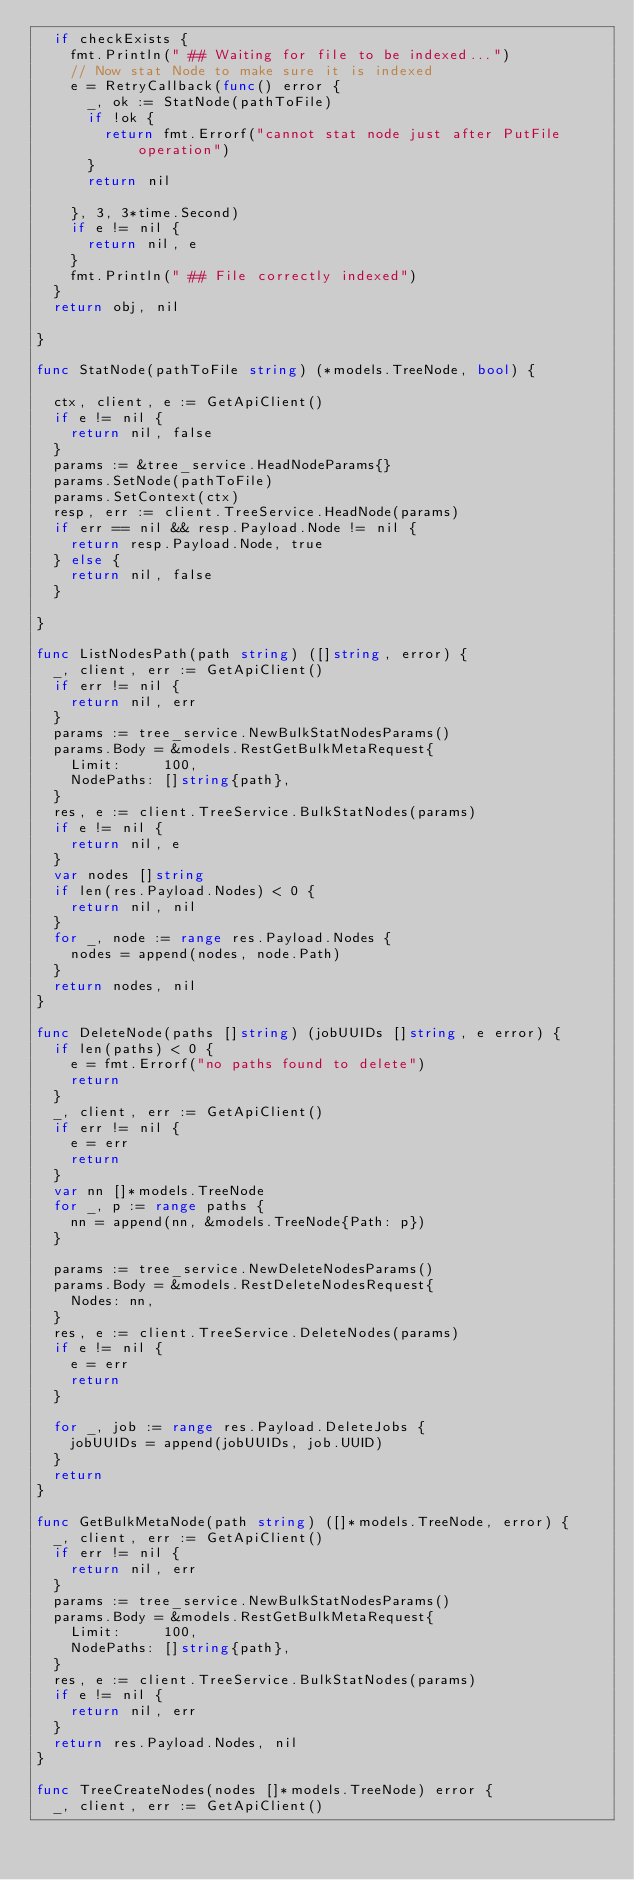<code> <loc_0><loc_0><loc_500><loc_500><_Go_>	if checkExists {
		fmt.Println(" ## Waiting for file to be indexed...")
		// Now stat Node to make sure it is indexed
		e = RetryCallback(func() error {
			_, ok := StatNode(pathToFile)
			if !ok {
				return fmt.Errorf("cannot stat node just after PutFile operation")
			}
			return nil

		}, 3, 3*time.Second)
		if e != nil {
			return nil, e
		}
		fmt.Println(" ## File correctly indexed")
	}
	return obj, nil

}

func StatNode(pathToFile string) (*models.TreeNode, bool) {

	ctx, client, e := GetApiClient()
	if e != nil {
		return nil, false
	}
	params := &tree_service.HeadNodeParams{}
	params.SetNode(pathToFile)
	params.SetContext(ctx)
	resp, err := client.TreeService.HeadNode(params)
	if err == nil && resp.Payload.Node != nil {
		return resp.Payload.Node, true
	} else {
		return nil, false
	}

}

func ListNodesPath(path string) ([]string, error) {
	_, client, err := GetApiClient()
	if err != nil {
		return nil, err
	}
	params := tree_service.NewBulkStatNodesParams()
	params.Body = &models.RestGetBulkMetaRequest{
		Limit:     100,
		NodePaths: []string{path},
	}
	res, e := client.TreeService.BulkStatNodes(params)
	if e != nil {
		return nil, e
	}
	var nodes []string
	if len(res.Payload.Nodes) < 0 {
		return nil, nil
	}
	for _, node := range res.Payload.Nodes {
		nodes = append(nodes, node.Path)
	}
	return nodes, nil
}

func DeleteNode(paths []string) (jobUUIDs []string, e error) {
	if len(paths) < 0 {
		e = fmt.Errorf("no paths found to delete")
		return
	}
	_, client, err := GetApiClient()
	if err != nil {
		e = err
		return
	}
	var nn []*models.TreeNode
	for _, p := range paths {
		nn = append(nn, &models.TreeNode{Path: p})
	}

	params := tree_service.NewDeleteNodesParams()
	params.Body = &models.RestDeleteNodesRequest{
		Nodes: nn,
	}
	res, e := client.TreeService.DeleteNodes(params)
	if e != nil {
		e = err
		return
	}

	for _, job := range res.Payload.DeleteJobs {
		jobUUIDs = append(jobUUIDs, job.UUID)
	}
	return
}

func GetBulkMetaNode(path string) ([]*models.TreeNode, error) {
	_, client, err := GetApiClient()
	if err != nil {
		return nil, err
	}
	params := tree_service.NewBulkStatNodesParams()
	params.Body = &models.RestGetBulkMetaRequest{
		Limit:     100,
		NodePaths: []string{path},
	}
	res, e := client.TreeService.BulkStatNodes(params)
	if e != nil {
		return nil, err
	}
	return res.Payload.Nodes, nil
}

func TreeCreateNodes(nodes []*models.TreeNode) error {
	_, client, err := GetApiClient()</code> 